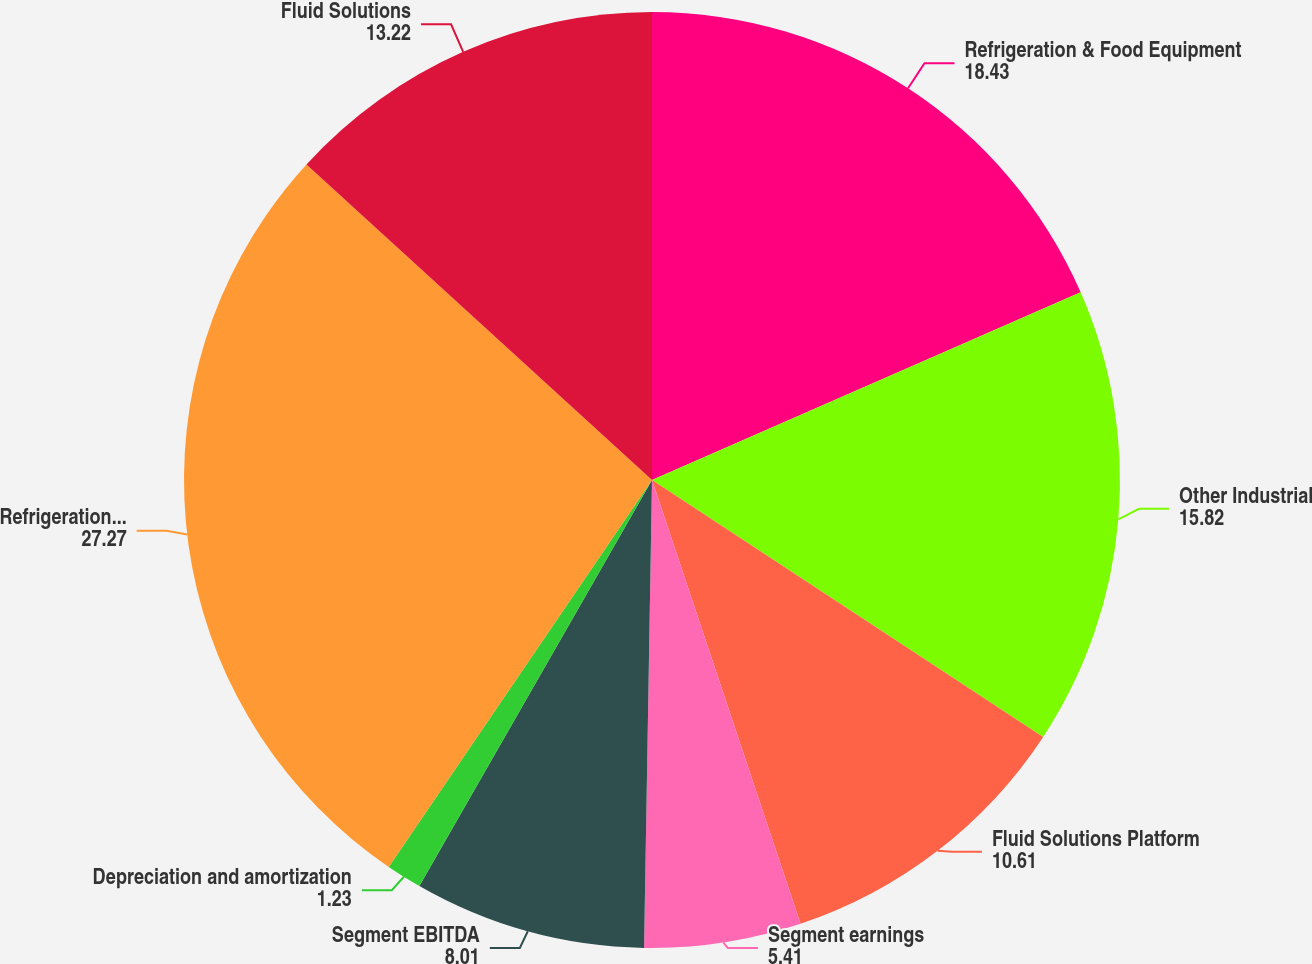Convert chart. <chart><loc_0><loc_0><loc_500><loc_500><pie_chart><fcel>Refrigeration & Food Equipment<fcel>Other Industrial<fcel>Fluid Solutions Platform<fcel>Segment earnings<fcel>Segment EBITDA<fcel>Depreciation and amortization<fcel>Refrigeration & Industrial<fcel>Fluid Solutions<nl><fcel>18.43%<fcel>15.82%<fcel>10.61%<fcel>5.41%<fcel>8.01%<fcel>1.23%<fcel>27.27%<fcel>13.22%<nl></chart> 